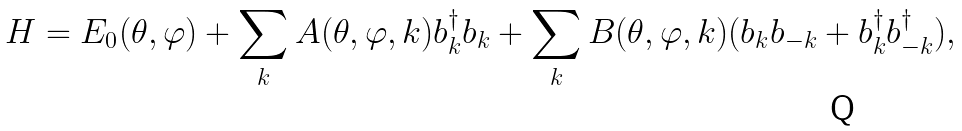Convert formula to latex. <formula><loc_0><loc_0><loc_500><loc_500>H = E _ { 0 } ( \theta , \varphi ) + \sum _ { k } A ( \theta , \varphi , k ) b _ { k } ^ { \dagger } b _ { k } + \sum _ { k } B ( \theta , \varphi , k ) ( b _ { k } b _ { - k } + b _ { k } ^ { \dagger } b _ { - k } ^ { \dagger } ) ,</formula> 